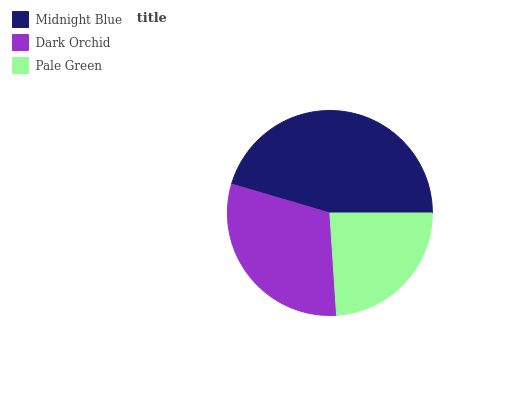Is Pale Green the minimum?
Answer yes or no. Yes. Is Midnight Blue the maximum?
Answer yes or no. Yes. Is Dark Orchid the minimum?
Answer yes or no. No. Is Dark Orchid the maximum?
Answer yes or no. No. Is Midnight Blue greater than Dark Orchid?
Answer yes or no. Yes. Is Dark Orchid less than Midnight Blue?
Answer yes or no. Yes. Is Dark Orchid greater than Midnight Blue?
Answer yes or no. No. Is Midnight Blue less than Dark Orchid?
Answer yes or no. No. Is Dark Orchid the high median?
Answer yes or no. Yes. Is Dark Orchid the low median?
Answer yes or no. Yes. Is Midnight Blue the high median?
Answer yes or no. No. Is Midnight Blue the low median?
Answer yes or no. No. 